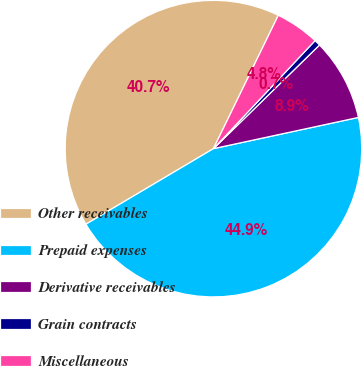Convert chart to OTSL. <chart><loc_0><loc_0><loc_500><loc_500><pie_chart><fcel>Other receivables<fcel>Prepaid expenses<fcel>Derivative receivables<fcel>Grain contracts<fcel>Miscellaneous<nl><fcel>40.72%<fcel>44.86%<fcel>8.94%<fcel>0.67%<fcel>4.81%<nl></chart> 